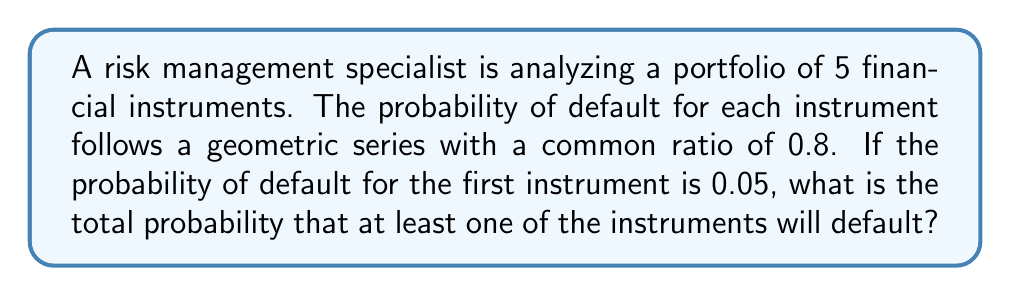Can you answer this question? Let's approach this step-by-step:

1) First, we need to identify the probabilities of default for each instrument. Given that it follows a geometric series with a first term of 0.05 and a common ratio of 0.8, we can express this as:

   $a_n = 0.05 \cdot (0.8)^{n-1}$ where $n$ is the instrument number

2) The probabilities for each instrument are:
   Instrument 1: $0.05$
   Instrument 2: $0.05 \cdot 0.8 = 0.04$
   Instrument 3: $0.05 \cdot 0.8^2 = 0.032$
   Instrument 4: $0.05 \cdot 0.8^3 = 0.0256$
   Instrument 5: $0.05 \cdot 0.8^4 = 0.02048$

3) To find the probability that at least one instrument will default, it's easier to calculate the probability that no instruments will default and then subtract this from 1.

4) The probability that an instrument will not default is 1 minus the probability that it will default. So, the probabilities of no default are:
   Instrument 1: $1 - 0.05 = 0.95$
   Instrument 2: $1 - 0.04 = 0.96$
   Instrument 3: $1 - 0.032 = 0.968$
   Instrument 4: $1 - 0.0256 = 0.9744$
   Instrument 5: $1 - 0.02048 = 0.97952$

5) The probability that all instruments will not default is the product of these probabilities:

   $P(\text{no defaults}) = 0.95 \cdot 0.96 \cdot 0.968 \cdot 0.9744 \cdot 0.97952 = 0.8456$

6) Therefore, the probability that at least one instrument will default is:

   $P(\text{at least one default}) = 1 - P(\text{no defaults}) = 1 - 0.8456 = 0.1544$
Answer: The probability that at least one of the instruments will default is approximately $0.1544$ or $15.44\%$. 